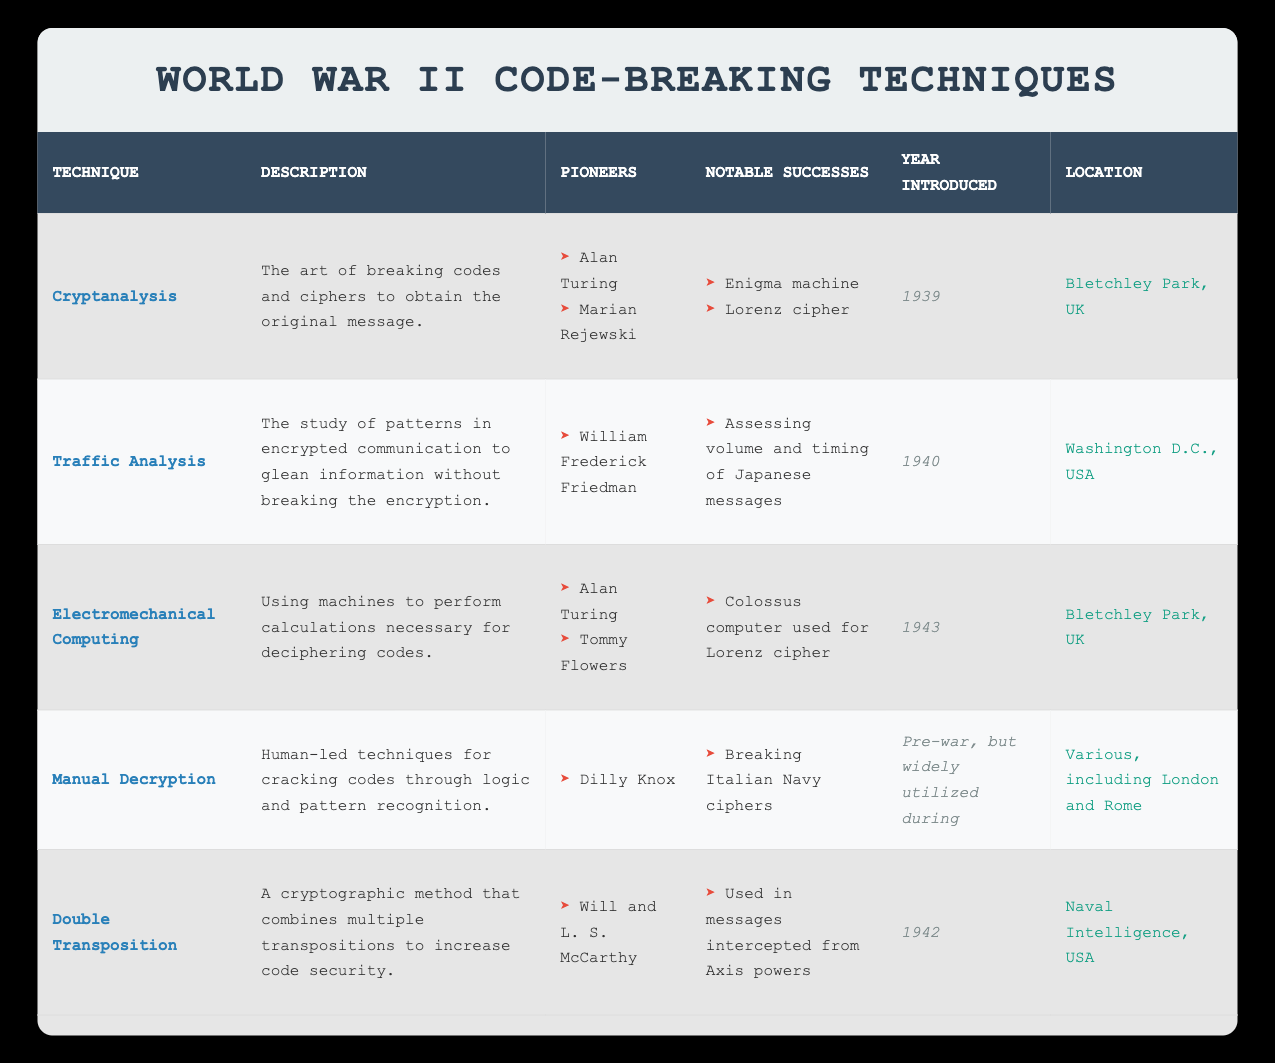What was the first code-breaking technique introduced during World War II? From the table, the code-breaking technique introduced first in the year 1939 is Cryptanalysis.
Answer: Cryptanalysis How many techniques mentioned in the table were introduced in the year 1942 or later? The techniques introduced in 1942 and 1943 are Double Transposition (1942) and Electromechanical Computing (1943). There are 2 techniques introduced in that time frame.
Answer: 2 Was Manual Decryption a technique used primarily after the war? According to the table, Manual Decryption was utilized widely during the war, but it originated before the war. Thus, it was not primarily a post-war technique.
Answer: No Who were the pioneers behind the technique of Electromechanical Computing? The table lists Alan Turing and Tommy Flowers as pioneers of Electromechanical Computing.
Answer: Alan Turing and Tommy Flowers What notable success is associated with the Traffic Analysis technique? The table states that the notable success associated with Traffic Analysis was assessing the volume and timing of Japanese messages.
Answer: Assessing volume and timing of Japanese messages How does the number of pioneers for Cryptanalysis compare to those for Manual Decryption? Cryptanalysis has 2 pioneers (Alan Turing, Marian Rejewski) while Manual Decryption has 1 pioneer (Dilly Knox), so Cryptanalysis has 1 more pioneer than Manual Decryption.
Answer: Cryptanalysis has 1 more pioneer Which technique was first introduced in Washington D.C., USA? From the table, Traffic Analysis was the technique first introduced in Washington D.C., USA in 1940.
Answer: Traffic Analysis Which location was common for the techniques introduced in both 1939 and 1943? Both Cryptanalysis (1939) and Electromechanical Computing (1943) were introduced at Bletchley Park, UK, making it a common location for these techniques.
Answer: Bletchley Park, UK What is the range of years in which the techniques were introduced according to the table? The earliest technique was introduced in 1939 and the latest in 1943, so the range is from 1939 to 1943.
Answer: 1939 to 1943 How many techniques included the term "cipher" in their notable successes? The table indicates that Cryptanalysis includes "Lorenz cipher" and Electromechanical Computing also includes "Lorenz cipher" in its notable successes. This totals to 2 techniques mentioning "cipher."
Answer: 2 